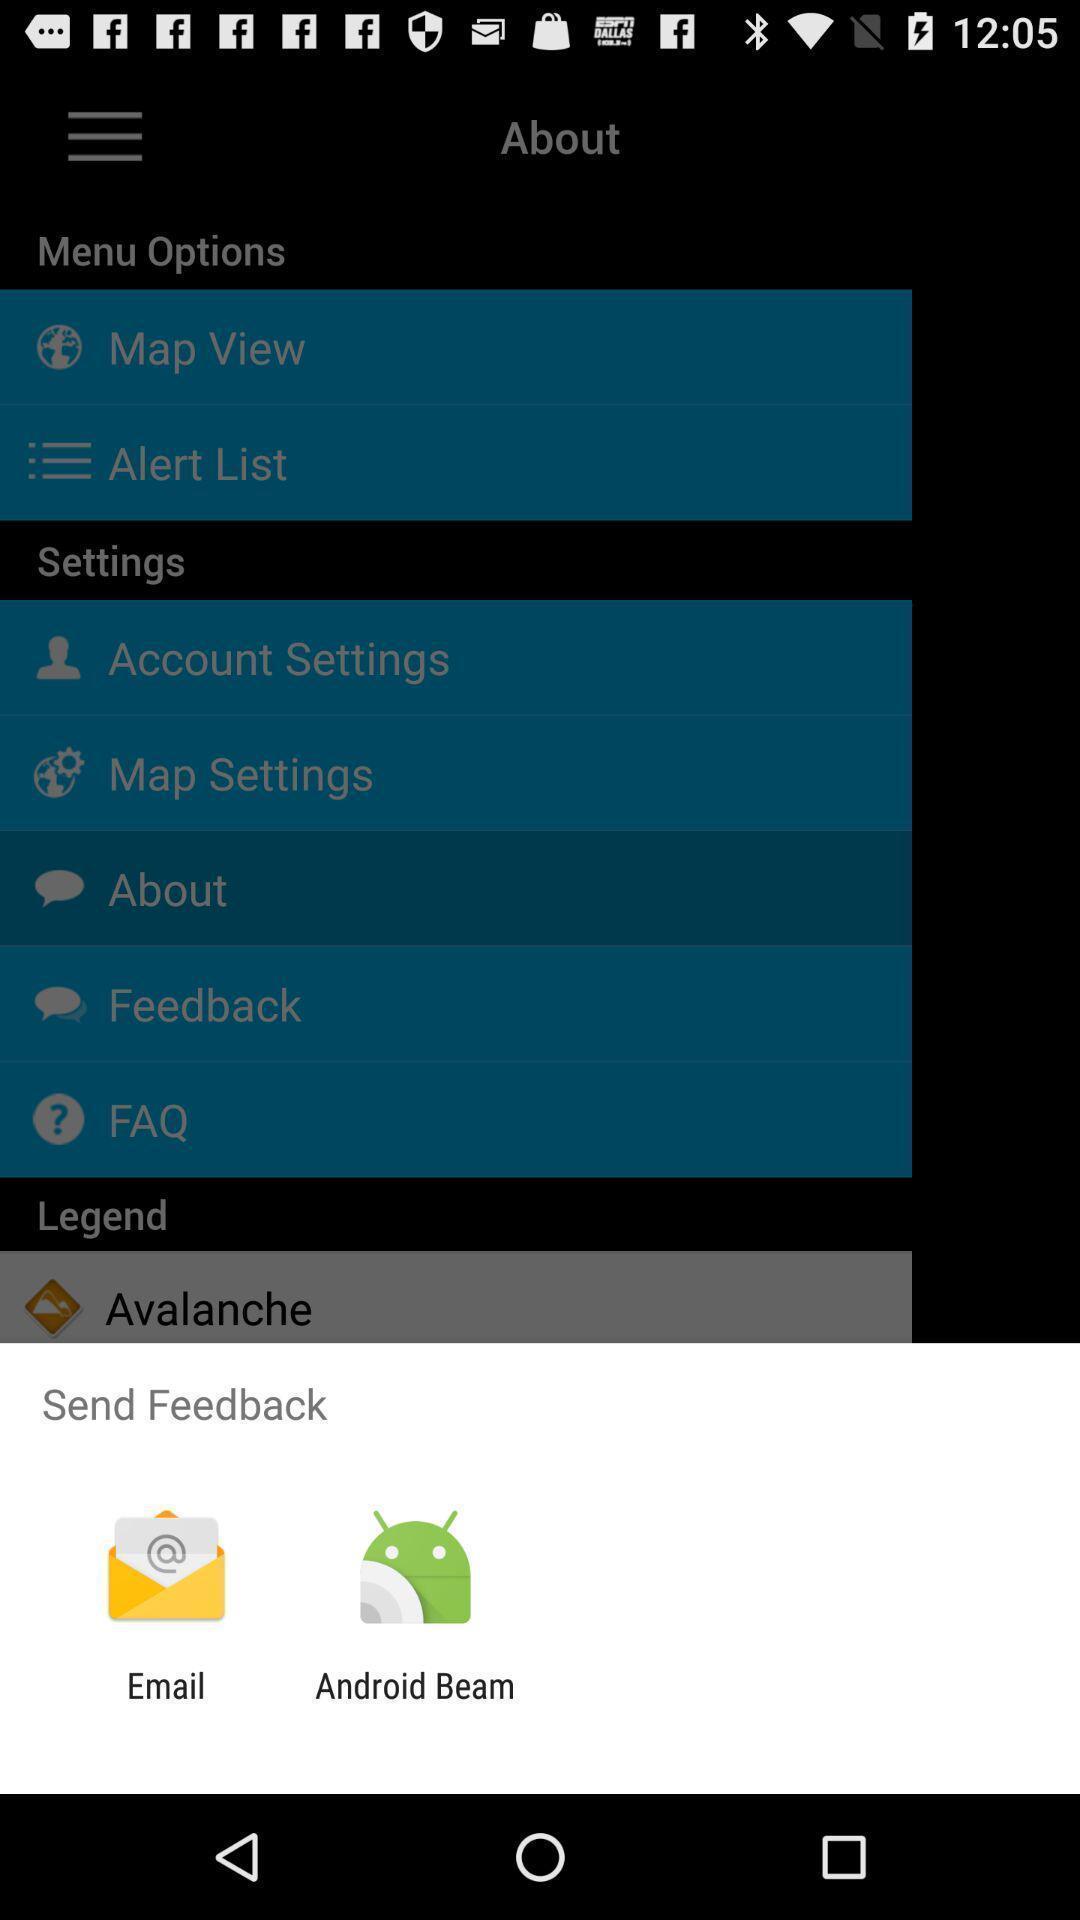Provide a textual representation of this image. Push up message with options to send feedback. 